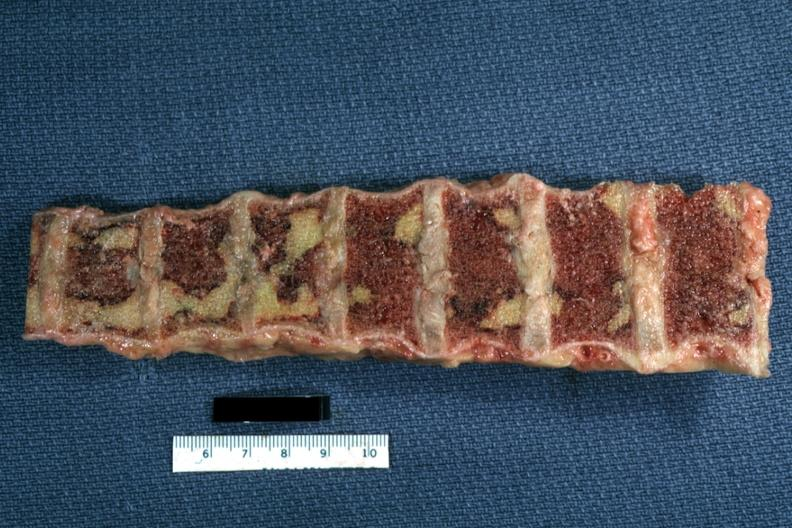what does this image show?
Answer the question using a single word or phrase. Vertebral bodies with large necrotic yellow areas case of chronic lymphocytic leukemia progressing to acute lymphocytic leukemia 